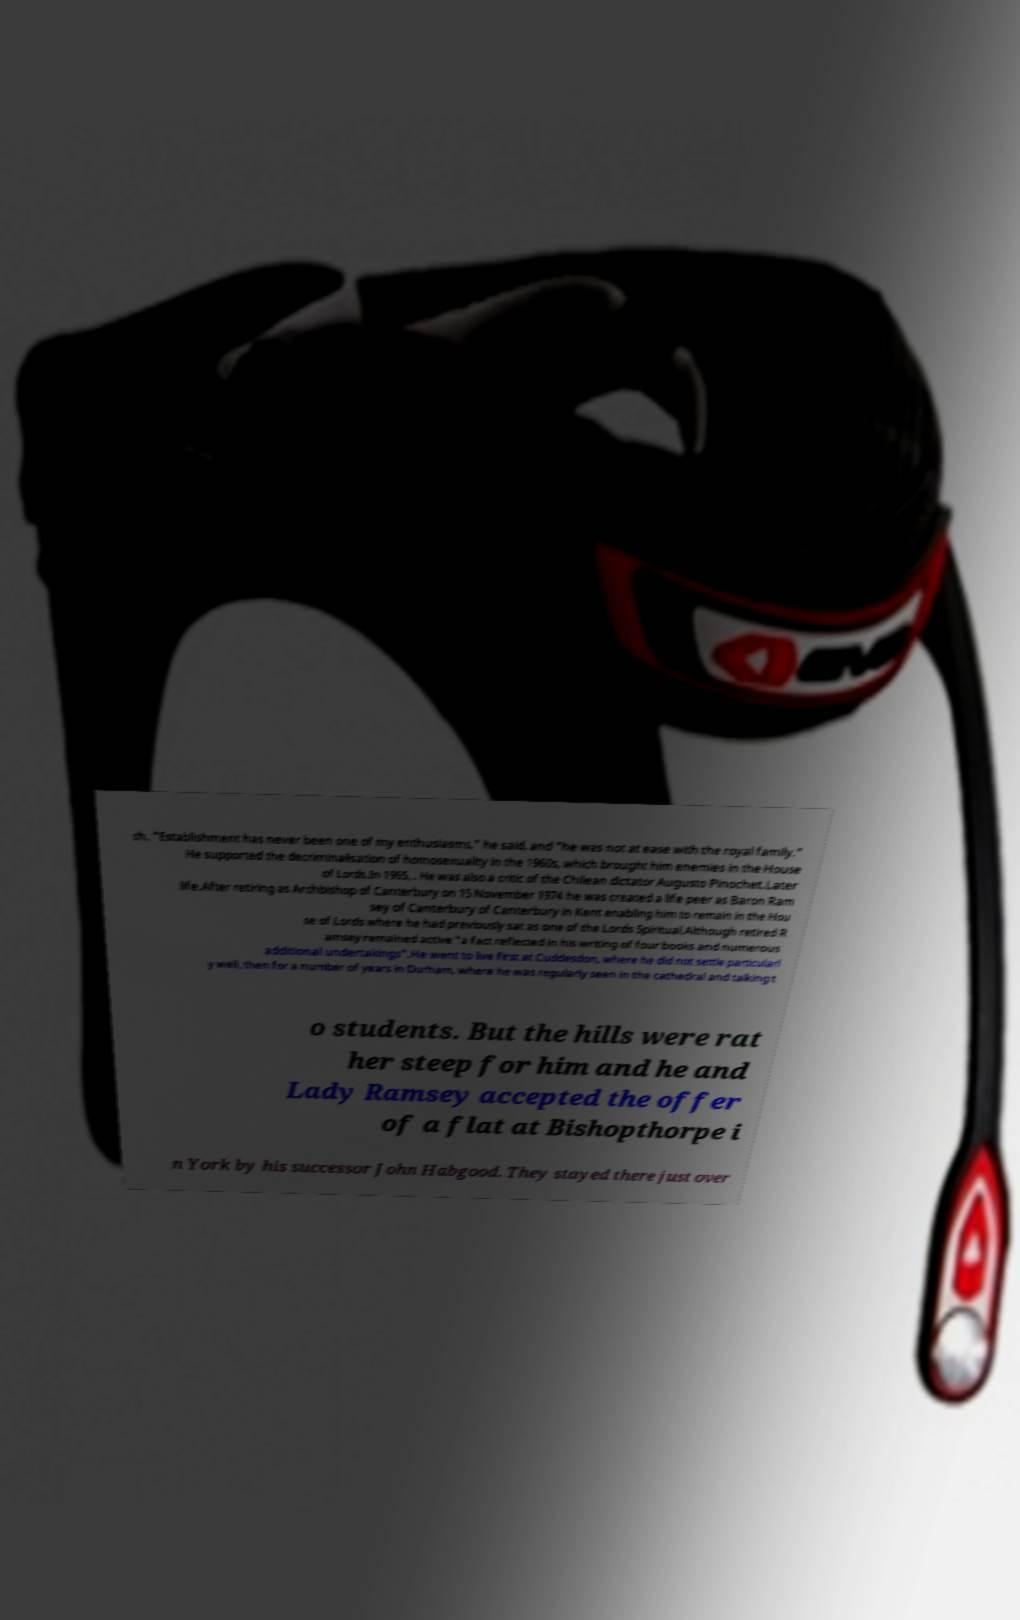I need the written content from this picture converted into text. Can you do that? ch. "Establishment has never been one of my enthusiasms," he said, and "he was not at ease with the royal family." He supported the decriminalisation of homosexuality in the 1960s, which brought him enemies in the House of Lords.In 1965, . He was also a critic of the Chilean dictator Augusto Pinochet.Later life.After retiring as Archbishop of Canterbury on 15 November 1974 he was created a life peer as Baron Ram sey of Canterbury of Canterbury in Kent enabling him to remain in the Hou se of Lords where he had previously sat as one of the Lords Spiritual.Although retired R amsey remained active "a fact reflected in his writing of four books and numerous additional undertakings".He went to live first at Cuddesdon, where he did not settle particularl y well, then for a number of years in Durham, where he was regularly seen in the cathedral and talking t o students. But the hills were rat her steep for him and he and Lady Ramsey accepted the offer of a flat at Bishopthorpe i n York by his successor John Habgood. They stayed there just over 